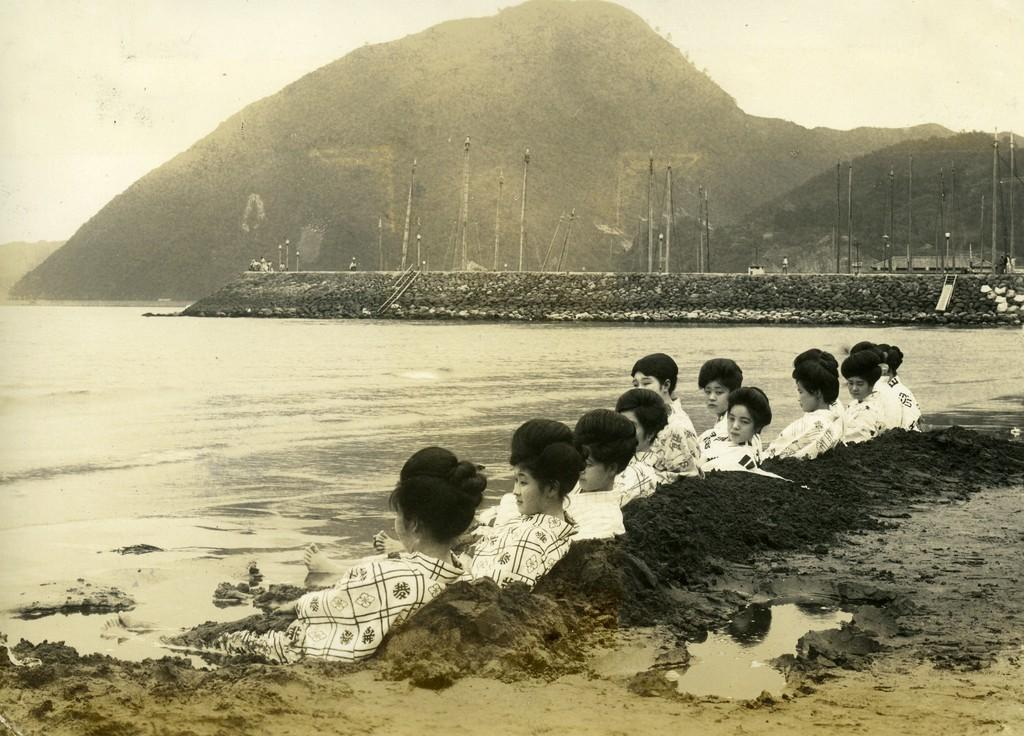What are the ladies in the image doing? The ladies are sitting on the ground in the center of the image. What is in front of the ladies? There is a river in front of the ladies. What can be seen in the background of the image? There are poles visible in the background of the image. What is visible at the top of the image? The sky is visible at the top of the image. What type of pies are being baked in the oven in the image? There is no oven or pies present in the image; it features ladies sitting on the ground with a river in front of them. Can you see a pipe in the image? There is no pipe visible in the image. 